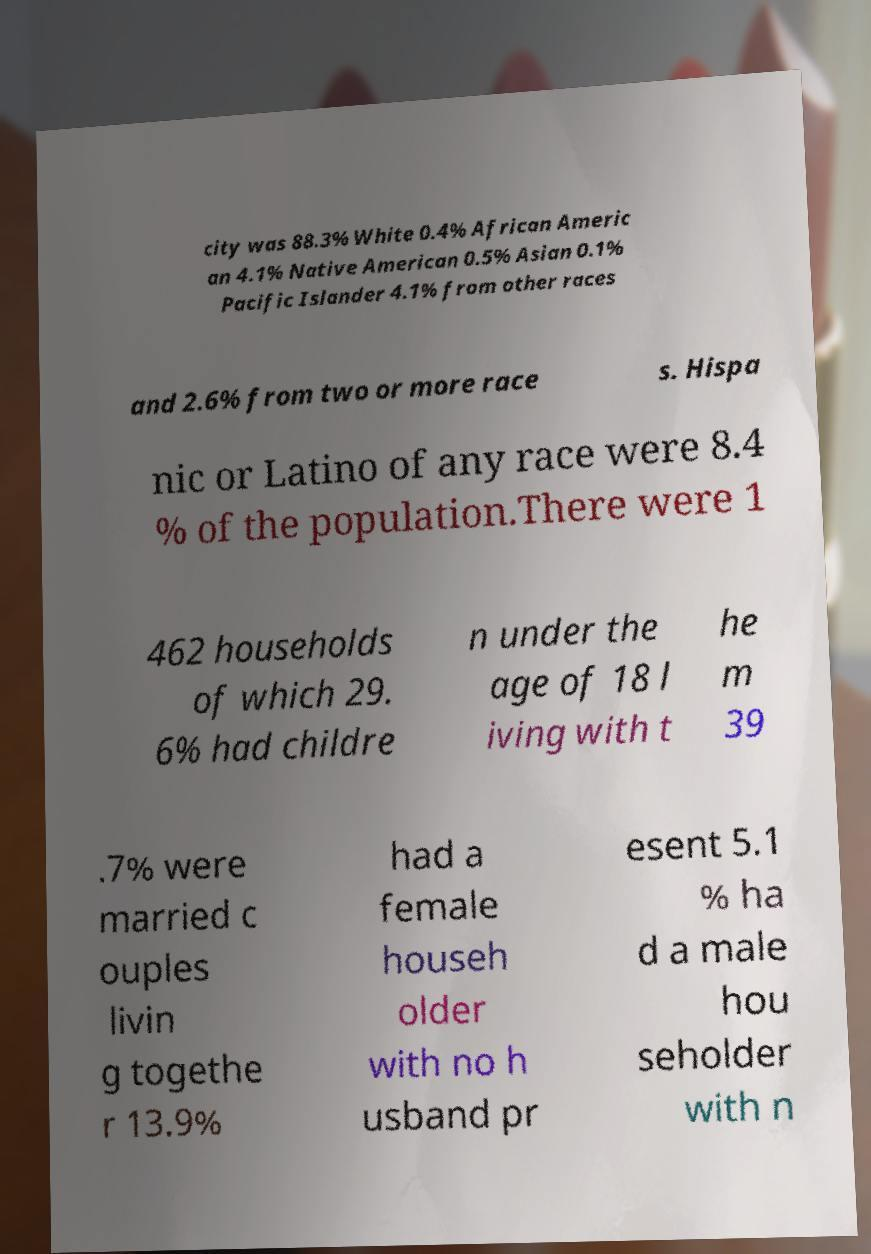For documentation purposes, I need the text within this image transcribed. Could you provide that? city was 88.3% White 0.4% African Americ an 4.1% Native American 0.5% Asian 0.1% Pacific Islander 4.1% from other races and 2.6% from two or more race s. Hispa nic or Latino of any race were 8.4 % of the population.There were 1 462 households of which 29. 6% had childre n under the age of 18 l iving with t he m 39 .7% were married c ouples livin g togethe r 13.9% had a female househ older with no h usband pr esent 5.1 % ha d a male hou seholder with n 